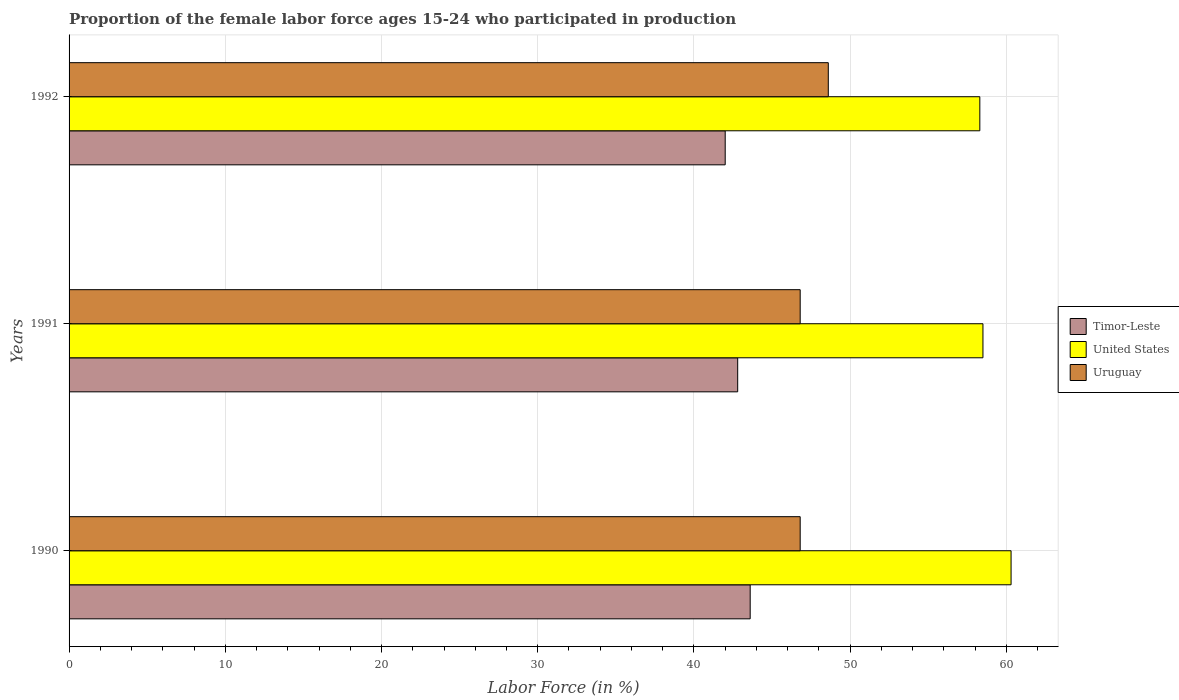How many different coloured bars are there?
Your answer should be very brief. 3. Are the number of bars on each tick of the Y-axis equal?
Make the answer very short. Yes. How many bars are there on the 3rd tick from the top?
Your answer should be compact. 3. How many bars are there on the 2nd tick from the bottom?
Ensure brevity in your answer.  3. What is the label of the 3rd group of bars from the top?
Your answer should be very brief. 1990. In how many cases, is the number of bars for a given year not equal to the number of legend labels?
Provide a short and direct response. 0. What is the proportion of the female labor force who participated in production in United States in 1990?
Ensure brevity in your answer.  60.3. Across all years, what is the maximum proportion of the female labor force who participated in production in Uruguay?
Your response must be concise. 48.6. In which year was the proportion of the female labor force who participated in production in United States maximum?
Your answer should be very brief. 1990. In which year was the proportion of the female labor force who participated in production in United States minimum?
Your answer should be compact. 1992. What is the total proportion of the female labor force who participated in production in United States in the graph?
Provide a succinct answer. 177.1. What is the difference between the proportion of the female labor force who participated in production in Uruguay in 1991 and that in 1992?
Offer a very short reply. -1.8. What is the difference between the proportion of the female labor force who participated in production in Uruguay in 1990 and the proportion of the female labor force who participated in production in United States in 1991?
Offer a terse response. -11.7. What is the average proportion of the female labor force who participated in production in United States per year?
Give a very brief answer. 59.03. In the year 1992, what is the difference between the proportion of the female labor force who participated in production in Uruguay and proportion of the female labor force who participated in production in Timor-Leste?
Your answer should be compact. 6.6. In how many years, is the proportion of the female labor force who participated in production in Timor-Leste greater than 16 %?
Offer a very short reply. 3. What is the ratio of the proportion of the female labor force who participated in production in Timor-Leste in 1990 to that in 1991?
Offer a terse response. 1.02. Is the proportion of the female labor force who participated in production in Timor-Leste in 1990 less than that in 1991?
Your answer should be very brief. No. What is the difference between the highest and the second highest proportion of the female labor force who participated in production in United States?
Your response must be concise. 1.8. What is the difference between the highest and the lowest proportion of the female labor force who participated in production in Timor-Leste?
Provide a succinct answer. 1.6. In how many years, is the proportion of the female labor force who participated in production in Timor-Leste greater than the average proportion of the female labor force who participated in production in Timor-Leste taken over all years?
Make the answer very short. 1. Is the sum of the proportion of the female labor force who participated in production in United States in 1990 and 1991 greater than the maximum proportion of the female labor force who participated in production in Timor-Leste across all years?
Provide a succinct answer. Yes. What does the 3rd bar from the top in 1991 represents?
Provide a short and direct response. Timor-Leste. What does the 2nd bar from the bottom in 1990 represents?
Your answer should be very brief. United States. How many bars are there?
Offer a terse response. 9. Are all the bars in the graph horizontal?
Offer a terse response. Yes. How many years are there in the graph?
Offer a very short reply. 3. Are the values on the major ticks of X-axis written in scientific E-notation?
Provide a succinct answer. No. Does the graph contain grids?
Offer a terse response. Yes. Where does the legend appear in the graph?
Offer a terse response. Center right. What is the title of the graph?
Ensure brevity in your answer.  Proportion of the female labor force ages 15-24 who participated in production. What is the label or title of the Y-axis?
Ensure brevity in your answer.  Years. What is the Labor Force (in %) in Timor-Leste in 1990?
Ensure brevity in your answer.  43.6. What is the Labor Force (in %) in United States in 1990?
Provide a succinct answer. 60.3. What is the Labor Force (in %) in Uruguay in 1990?
Provide a succinct answer. 46.8. What is the Labor Force (in %) in Timor-Leste in 1991?
Provide a short and direct response. 42.8. What is the Labor Force (in %) in United States in 1991?
Provide a short and direct response. 58.5. What is the Labor Force (in %) of Uruguay in 1991?
Offer a terse response. 46.8. What is the Labor Force (in %) in Timor-Leste in 1992?
Make the answer very short. 42. What is the Labor Force (in %) in United States in 1992?
Ensure brevity in your answer.  58.3. What is the Labor Force (in %) of Uruguay in 1992?
Offer a very short reply. 48.6. Across all years, what is the maximum Labor Force (in %) of Timor-Leste?
Ensure brevity in your answer.  43.6. Across all years, what is the maximum Labor Force (in %) of United States?
Provide a short and direct response. 60.3. Across all years, what is the maximum Labor Force (in %) of Uruguay?
Keep it short and to the point. 48.6. Across all years, what is the minimum Labor Force (in %) in Timor-Leste?
Offer a very short reply. 42. Across all years, what is the minimum Labor Force (in %) in United States?
Provide a short and direct response. 58.3. Across all years, what is the minimum Labor Force (in %) in Uruguay?
Give a very brief answer. 46.8. What is the total Labor Force (in %) in Timor-Leste in the graph?
Provide a succinct answer. 128.4. What is the total Labor Force (in %) in United States in the graph?
Offer a very short reply. 177.1. What is the total Labor Force (in %) in Uruguay in the graph?
Ensure brevity in your answer.  142.2. What is the difference between the Labor Force (in %) of Uruguay in 1990 and that in 1991?
Ensure brevity in your answer.  0. What is the difference between the Labor Force (in %) of Timor-Leste in 1991 and that in 1992?
Your answer should be compact. 0.8. What is the difference between the Labor Force (in %) in Uruguay in 1991 and that in 1992?
Make the answer very short. -1.8. What is the difference between the Labor Force (in %) of Timor-Leste in 1990 and the Labor Force (in %) of United States in 1991?
Provide a succinct answer. -14.9. What is the difference between the Labor Force (in %) of Timor-Leste in 1990 and the Labor Force (in %) of Uruguay in 1991?
Your answer should be compact. -3.2. What is the difference between the Labor Force (in %) of United States in 1990 and the Labor Force (in %) of Uruguay in 1991?
Your answer should be very brief. 13.5. What is the difference between the Labor Force (in %) in Timor-Leste in 1990 and the Labor Force (in %) in United States in 1992?
Your response must be concise. -14.7. What is the difference between the Labor Force (in %) of Timor-Leste in 1990 and the Labor Force (in %) of Uruguay in 1992?
Ensure brevity in your answer.  -5. What is the difference between the Labor Force (in %) in Timor-Leste in 1991 and the Labor Force (in %) in United States in 1992?
Provide a short and direct response. -15.5. What is the difference between the Labor Force (in %) in Timor-Leste in 1991 and the Labor Force (in %) in Uruguay in 1992?
Your answer should be compact. -5.8. What is the difference between the Labor Force (in %) of United States in 1991 and the Labor Force (in %) of Uruguay in 1992?
Your answer should be very brief. 9.9. What is the average Labor Force (in %) of Timor-Leste per year?
Ensure brevity in your answer.  42.8. What is the average Labor Force (in %) of United States per year?
Keep it short and to the point. 59.03. What is the average Labor Force (in %) of Uruguay per year?
Provide a succinct answer. 47.4. In the year 1990, what is the difference between the Labor Force (in %) of Timor-Leste and Labor Force (in %) of United States?
Keep it short and to the point. -16.7. In the year 1991, what is the difference between the Labor Force (in %) of Timor-Leste and Labor Force (in %) of United States?
Give a very brief answer. -15.7. In the year 1991, what is the difference between the Labor Force (in %) of Timor-Leste and Labor Force (in %) of Uruguay?
Give a very brief answer. -4. In the year 1991, what is the difference between the Labor Force (in %) of United States and Labor Force (in %) of Uruguay?
Ensure brevity in your answer.  11.7. In the year 1992, what is the difference between the Labor Force (in %) in Timor-Leste and Labor Force (in %) in United States?
Offer a terse response. -16.3. What is the ratio of the Labor Force (in %) in Timor-Leste in 1990 to that in 1991?
Offer a very short reply. 1.02. What is the ratio of the Labor Force (in %) in United States in 1990 to that in 1991?
Offer a very short reply. 1.03. What is the ratio of the Labor Force (in %) of Uruguay in 1990 to that in 1991?
Provide a succinct answer. 1. What is the ratio of the Labor Force (in %) in Timor-Leste in 1990 to that in 1992?
Offer a very short reply. 1.04. What is the ratio of the Labor Force (in %) of United States in 1990 to that in 1992?
Ensure brevity in your answer.  1.03. What is the ratio of the Labor Force (in %) in United States in 1991 to that in 1992?
Your answer should be very brief. 1. What is the difference between the highest and the second highest Labor Force (in %) of Timor-Leste?
Keep it short and to the point. 0.8. What is the difference between the highest and the lowest Labor Force (in %) of Timor-Leste?
Provide a short and direct response. 1.6. What is the difference between the highest and the lowest Labor Force (in %) of United States?
Your answer should be very brief. 2. What is the difference between the highest and the lowest Labor Force (in %) of Uruguay?
Offer a very short reply. 1.8. 